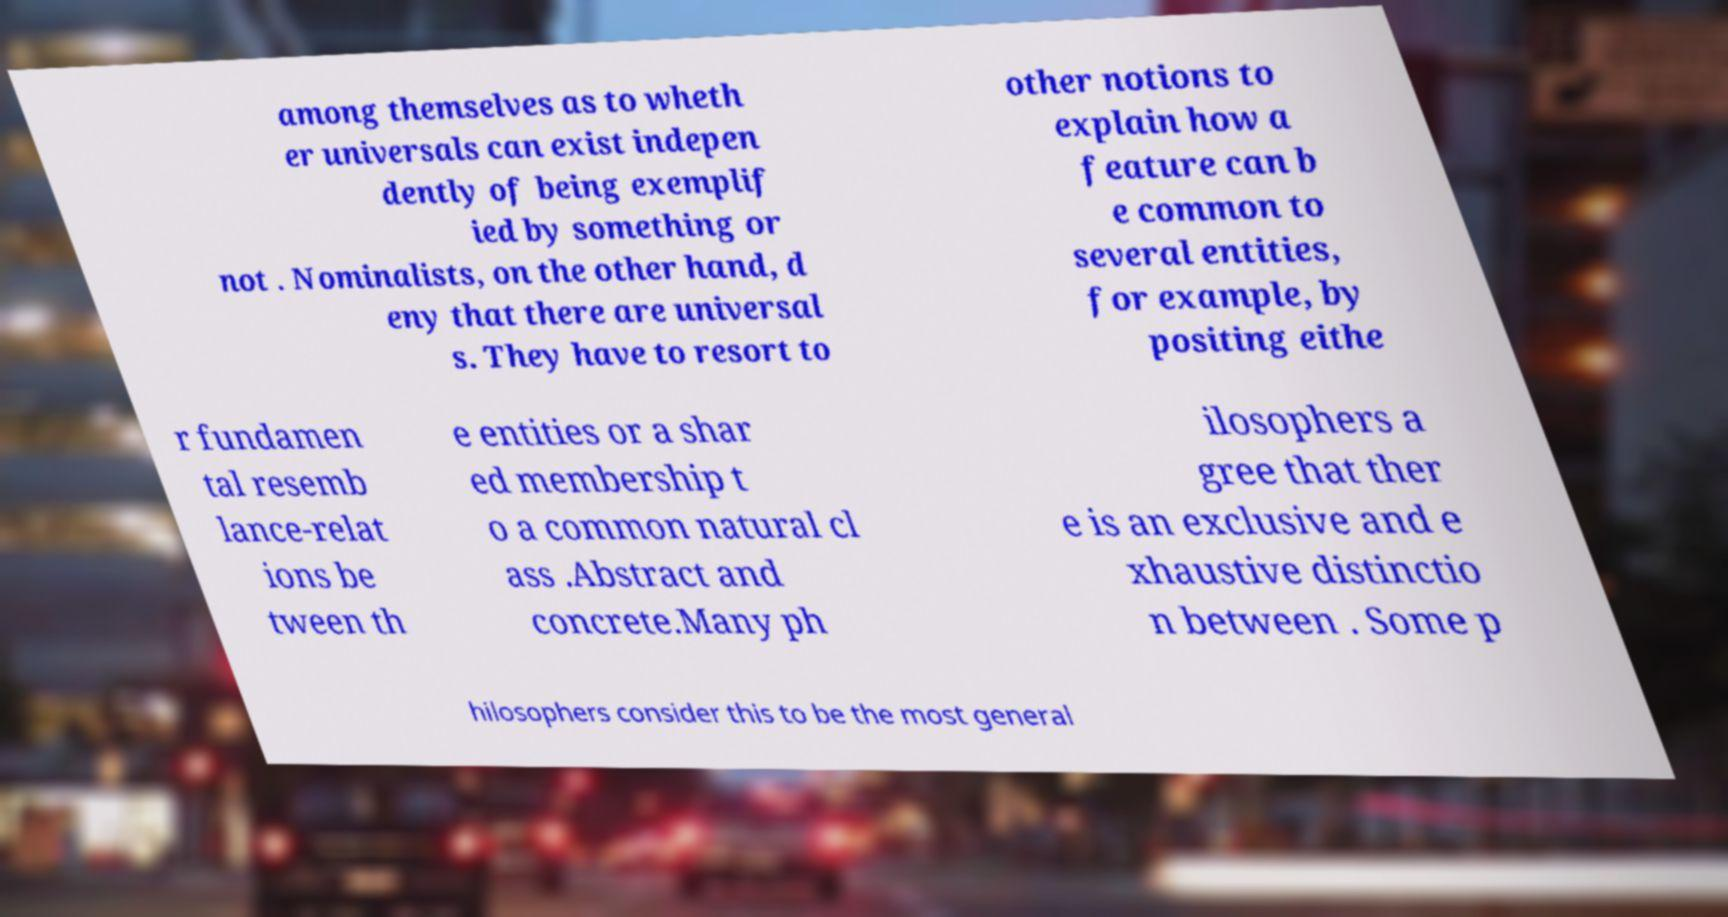Can you read and provide the text displayed in the image?This photo seems to have some interesting text. Can you extract and type it out for me? among themselves as to wheth er universals can exist indepen dently of being exemplif ied by something or not . Nominalists, on the other hand, d eny that there are universal s. They have to resort to other notions to explain how a feature can b e common to several entities, for example, by positing eithe r fundamen tal resemb lance-relat ions be tween th e entities or a shar ed membership t o a common natural cl ass .Abstract and concrete.Many ph ilosophers a gree that ther e is an exclusive and e xhaustive distinctio n between . Some p hilosophers consider this to be the most general 